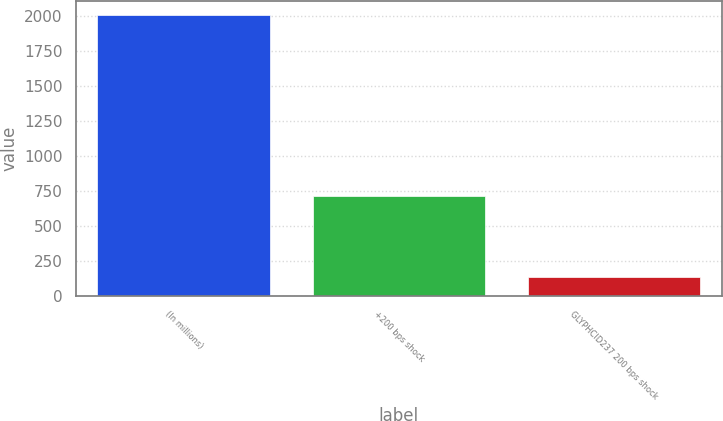Convert chart. <chart><loc_0><loc_0><loc_500><loc_500><bar_chart><fcel>(In millions)<fcel>+200 bps shock<fcel>GLYPHCID237 200 bps shock<nl><fcel>2005<fcel>714<fcel>138<nl></chart> 